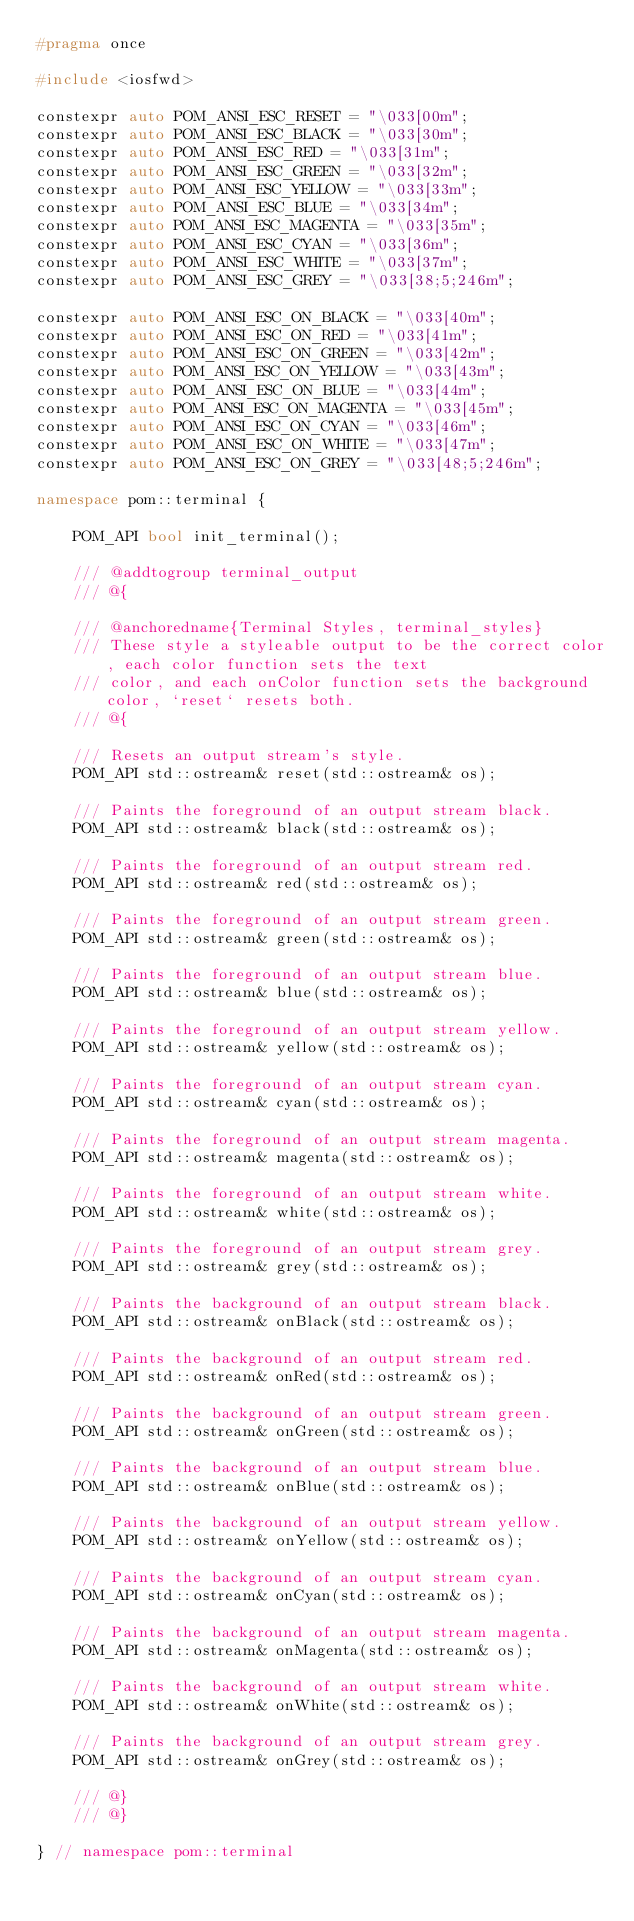<code> <loc_0><loc_0><loc_500><loc_500><_C++_>#pragma once

#include <iosfwd>

constexpr auto POM_ANSI_ESC_RESET = "\033[00m";
constexpr auto POM_ANSI_ESC_BLACK = "\033[30m";
constexpr auto POM_ANSI_ESC_RED = "\033[31m";
constexpr auto POM_ANSI_ESC_GREEN = "\033[32m";
constexpr auto POM_ANSI_ESC_YELLOW = "\033[33m";
constexpr auto POM_ANSI_ESC_BLUE = "\033[34m";
constexpr auto POM_ANSI_ESC_MAGENTA = "\033[35m";
constexpr auto POM_ANSI_ESC_CYAN = "\033[36m";
constexpr auto POM_ANSI_ESC_WHITE = "\033[37m";
constexpr auto POM_ANSI_ESC_GREY = "\033[38;5;246m";

constexpr auto POM_ANSI_ESC_ON_BLACK = "\033[40m";
constexpr auto POM_ANSI_ESC_ON_RED = "\033[41m";
constexpr auto POM_ANSI_ESC_ON_GREEN = "\033[42m";
constexpr auto POM_ANSI_ESC_ON_YELLOW = "\033[43m";
constexpr auto POM_ANSI_ESC_ON_BLUE = "\033[44m";
constexpr auto POM_ANSI_ESC_ON_MAGENTA = "\033[45m";
constexpr auto POM_ANSI_ESC_ON_CYAN = "\033[46m";
constexpr auto POM_ANSI_ESC_ON_WHITE = "\033[47m";
constexpr auto POM_ANSI_ESC_ON_GREY = "\033[48;5;246m";

namespace pom::terminal {

    POM_API bool init_terminal();

    /// @addtogroup terminal_output
    /// @{

    /// @anchoredname{Terminal Styles, terminal_styles}
    /// These style a styleable output to be the correct color, each color function sets the text
    /// color, and each onColor function sets the background color, `reset` resets both.
    /// @{

    /// Resets an output stream's style.
    POM_API std::ostream& reset(std::ostream& os);

    /// Paints the foreground of an output stream black.
    POM_API std::ostream& black(std::ostream& os);

    /// Paints the foreground of an output stream red.
    POM_API std::ostream& red(std::ostream& os);

    /// Paints the foreground of an output stream green.
    POM_API std::ostream& green(std::ostream& os);

    /// Paints the foreground of an output stream blue.
    POM_API std::ostream& blue(std::ostream& os);

    /// Paints the foreground of an output stream yellow.
    POM_API std::ostream& yellow(std::ostream& os);

    /// Paints the foreground of an output stream cyan.
    POM_API std::ostream& cyan(std::ostream& os);

    /// Paints the foreground of an output stream magenta.
    POM_API std::ostream& magenta(std::ostream& os);

    /// Paints the foreground of an output stream white.
    POM_API std::ostream& white(std::ostream& os);

    /// Paints the foreground of an output stream grey.
    POM_API std::ostream& grey(std::ostream& os);

    /// Paints the background of an output stream black.
    POM_API std::ostream& onBlack(std::ostream& os);

    /// Paints the background of an output stream red.
    POM_API std::ostream& onRed(std::ostream& os);

    /// Paints the background of an output stream green.
    POM_API std::ostream& onGreen(std::ostream& os);

    /// Paints the background of an output stream blue.
    POM_API std::ostream& onBlue(std::ostream& os);

    /// Paints the background of an output stream yellow.
    POM_API std::ostream& onYellow(std::ostream& os);

    /// Paints the background of an output stream cyan.
    POM_API std::ostream& onCyan(std::ostream& os);

    /// Paints the background of an output stream magenta.
    POM_API std::ostream& onMagenta(std::ostream& os);

    /// Paints the background of an output stream white.
    POM_API std::ostream& onWhite(std::ostream& os);

    /// Paints the background of an output stream grey.
    POM_API std::ostream& onGrey(std::ostream& os);

    /// @}
    /// @}

} // namespace pom::terminal</code> 